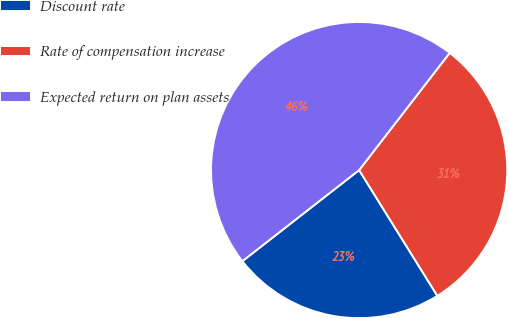Convert chart. <chart><loc_0><loc_0><loc_500><loc_500><pie_chart><fcel>Discount rate<fcel>Rate of compensation increase<fcel>Expected return on plan assets<nl><fcel>23.31%<fcel>30.67%<fcel>46.01%<nl></chart> 